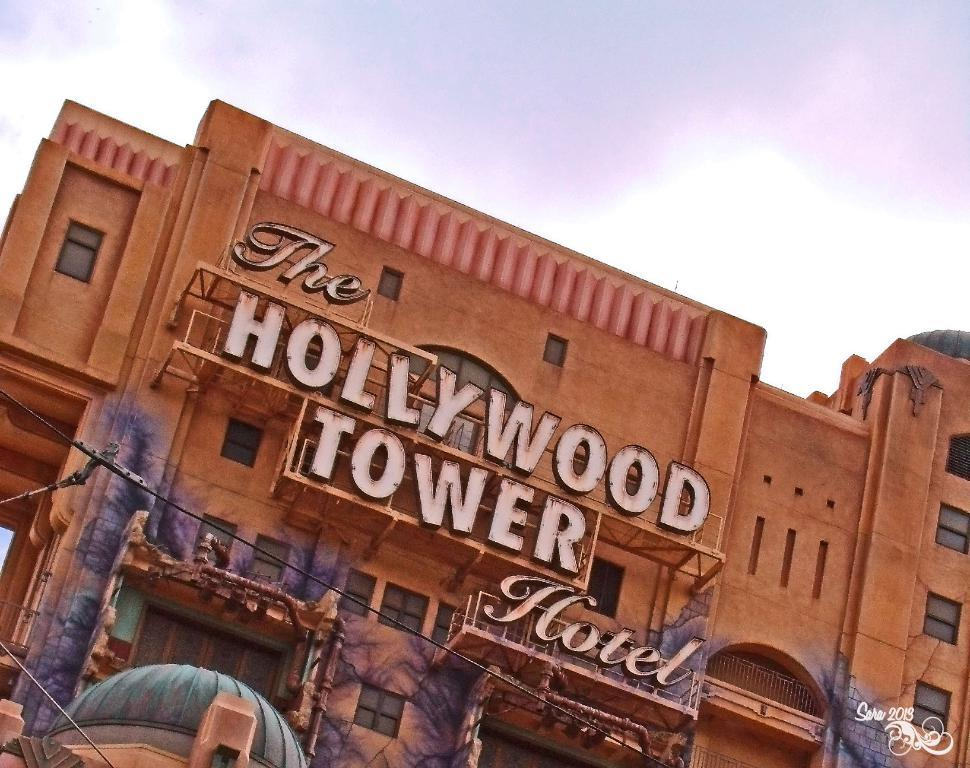What type of structure is in the image? There is a building in the image. What feature can be seen on the building? The building has windows. What else is visible in the image besides the building? There is text visible in the image, as well as electric wires. What is the condition of the sky in the image? The sky is visible in the image and appears to be cloudy. Can you see any spots on the building in the image? There is no mention of spots on the building in the provided facts, so we cannot determine if any are present. What type of wax is used to create the text in the image? There is no mention of wax being used to create the text in the image, so we cannot determine the type of wax used. 